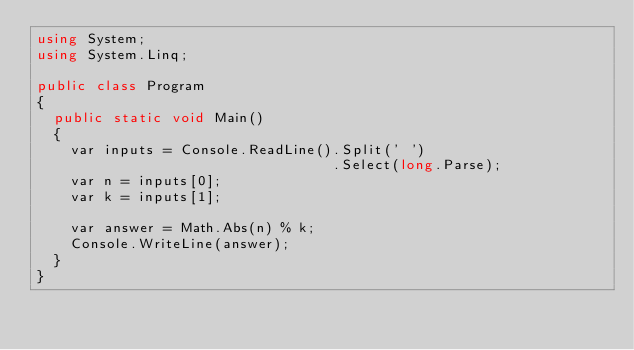<code> <loc_0><loc_0><loc_500><loc_500><_C#_>using System;
using System.Linq;
 
public class Program
{
  public static void Main()
  {
    var inputs = Console.ReadLine().Split(' ')
      							   .Select(long.Parse);
    var n = inputs[0];
    var k = inputs[1];
    
    var answer = Math.Abs(n) % k;
    Console.WriteLine(answer);
  }
}</code> 